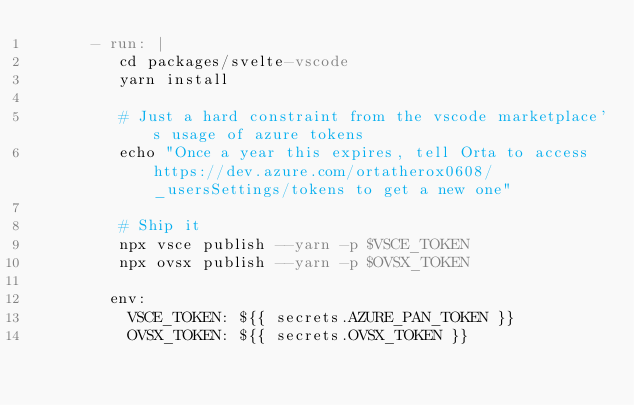<code> <loc_0><loc_0><loc_500><loc_500><_YAML_>      - run: |
         cd packages/svelte-vscode
         yarn install

         # Just a hard constraint from the vscode marketplace's usage of azure tokens
         echo "Once a year this expires, tell Orta to access https://dev.azure.com/ortatherox0608/_usersSettings/tokens to get a new one"

         # Ship it
         npx vsce publish --yarn -p $VSCE_TOKEN
         npx ovsx publish --yarn -p $OVSX_TOKEN

        env:
          VSCE_TOKEN: ${{ secrets.AZURE_PAN_TOKEN }}
          OVSX_TOKEN: ${{ secrets.OVSX_TOKEN }}
</code> 